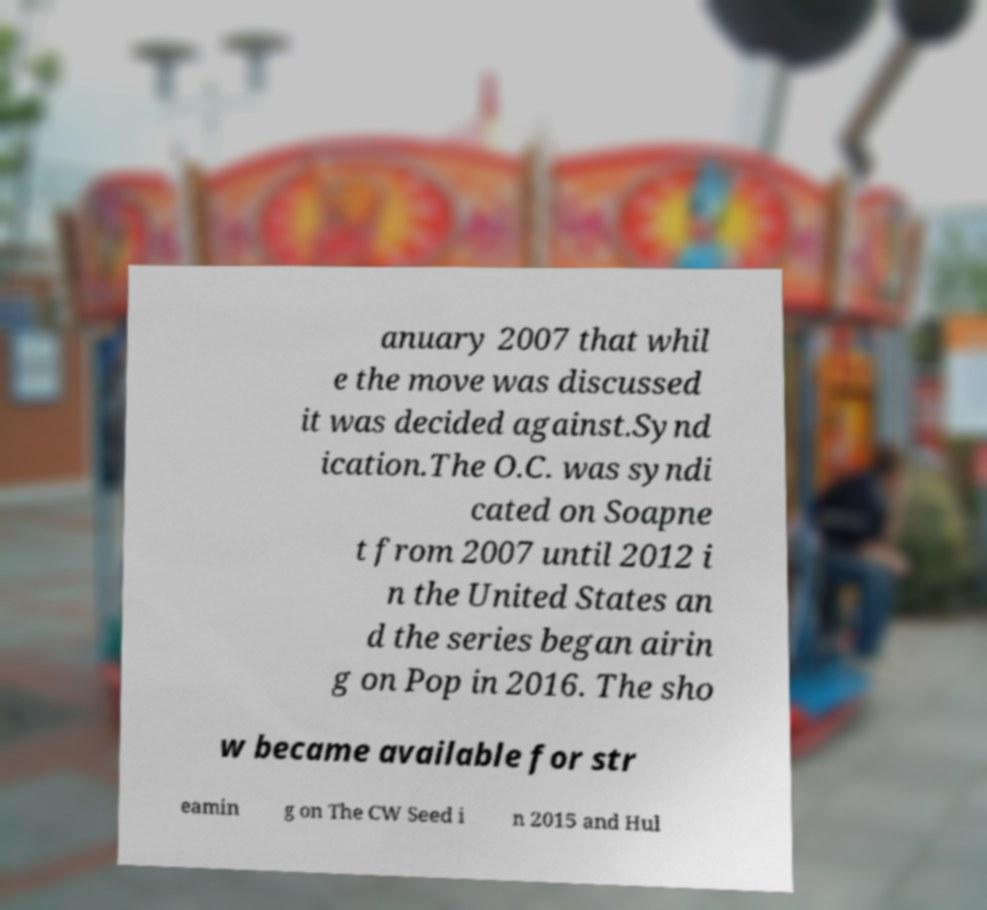Can you read and provide the text displayed in the image?This photo seems to have some interesting text. Can you extract and type it out for me? anuary 2007 that whil e the move was discussed it was decided against.Synd ication.The O.C. was syndi cated on Soapne t from 2007 until 2012 i n the United States an d the series began airin g on Pop in 2016. The sho w became available for str eamin g on The CW Seed i n 2015 and Hul 